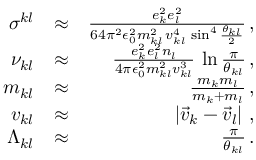<formula> <loc_0><loc_0><loc_500><loc_500>\begin{array} { r l r } { \sigma ^ { k l } } & { \approx } & { \frac { e _ { k } ^ { 2 } e _ { l } ^ { 2 } } { 6 4 \pi ^ { 2 } \epsilon _ { 0 } ^ { 2 } m _ { k l } ^ { 2 } \, v _ { k l } ^ { 4 } \, \sin ^ { 4 } \frac { \theta _ { k l } } { 2 } } \, , } \\ { \nu _ { k l } } & { \approx } & { \frac { e _ { k } ^ { 2 } e _ { l } ^ { 2 } n _ { l } } { 4 \pi \epsilon _ { 0 } ^ { 2 } m _ { k l } ^ { 2 } v _ { k l } ^ { 3 } } \, \ln \frac { \pi } { \theta _ { k l } } \, , } \\ { m _ { k l } } & { \approx } & { \frac { m _ { k } m _ { l } } { m _ { k } + m _ { l } } \, , } \\ { v _ { k l } } & { \approx } & { \left | \vec { v } _ { k } - \vec { v } _ { l } \right | \, , } \\ { \Lambda _ { k l } } & { \approx } & { \frac { \pi } { \theta _ { k l } } \, . } \end{array}</formula> 